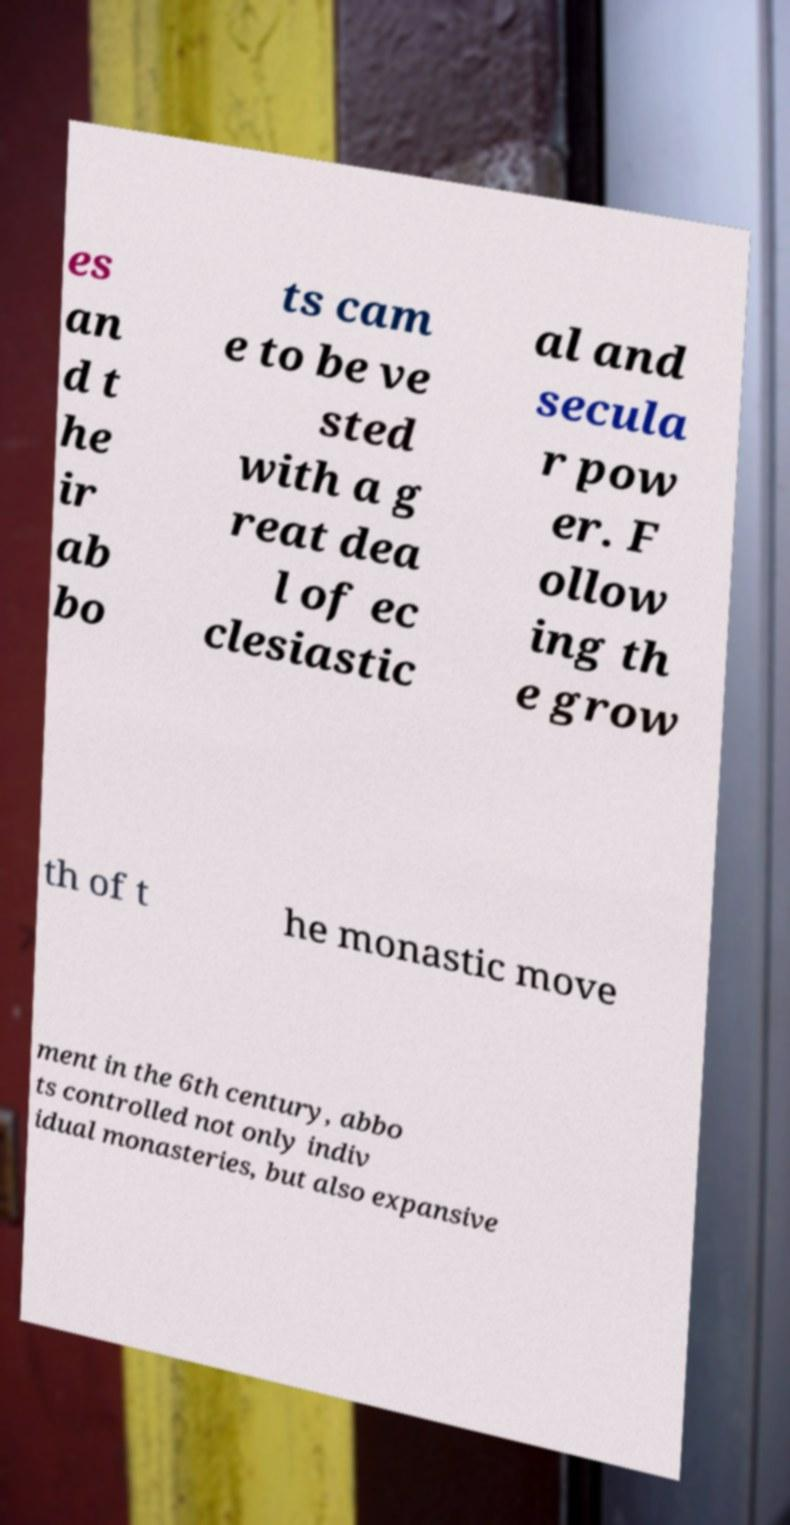For documentation purposes, I need the text within this image transcribed. Could you provide that? es an d t he ir ab bo ts cam e to be ve sted with a g reat dea l of ec clesiastic al and secula r pow er. F ollow ing th e grow th of t he monastic move ment in the 6th century, abbo ts controlled not only indiv idual monasteries, but also expansive 